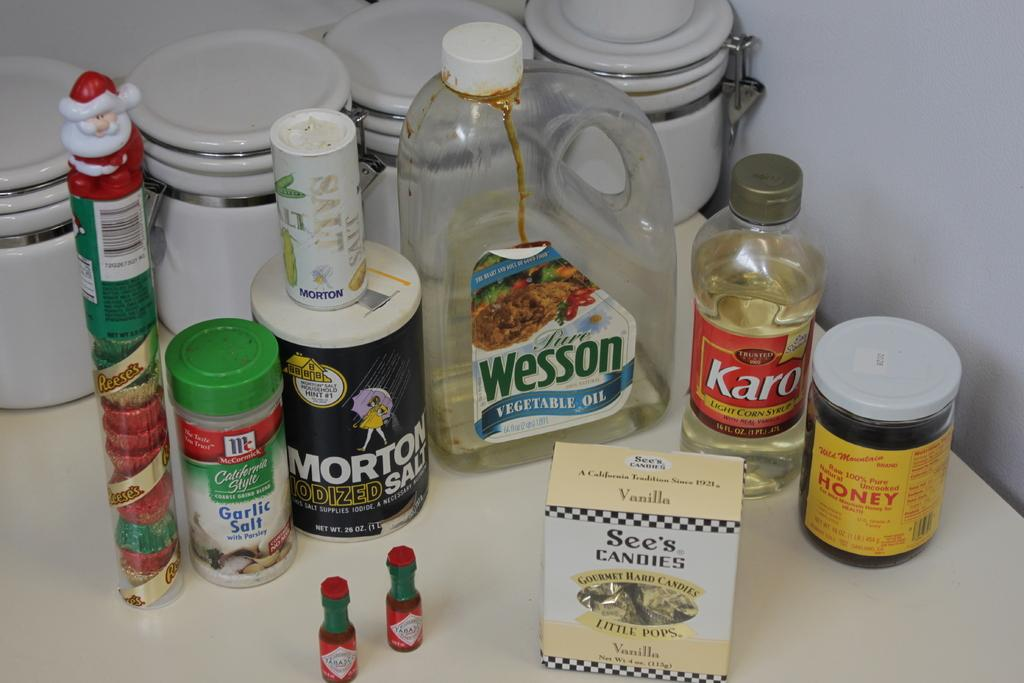Provide a one-sentence caption for the provided image. Several bottles and packets on a table with two small bottles of tabasco in front. 